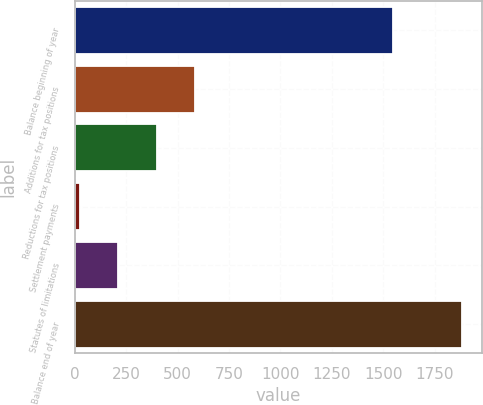Convert chart. <chart><loc_0><loc_0><loc_500><loc_500><bar_chart><fcel>Balance beginning of year<fcel>Additions for tax positions<fcel>Reductions for tax positions<fcel>Settlement payments<fcel>Statutes of limitations<fcel>Balance end of year<nl><fcel>1547<fcel>583.7<fcel>397.8<fcel>26<fcel>211.9<fcel>1885<nl></chart> 